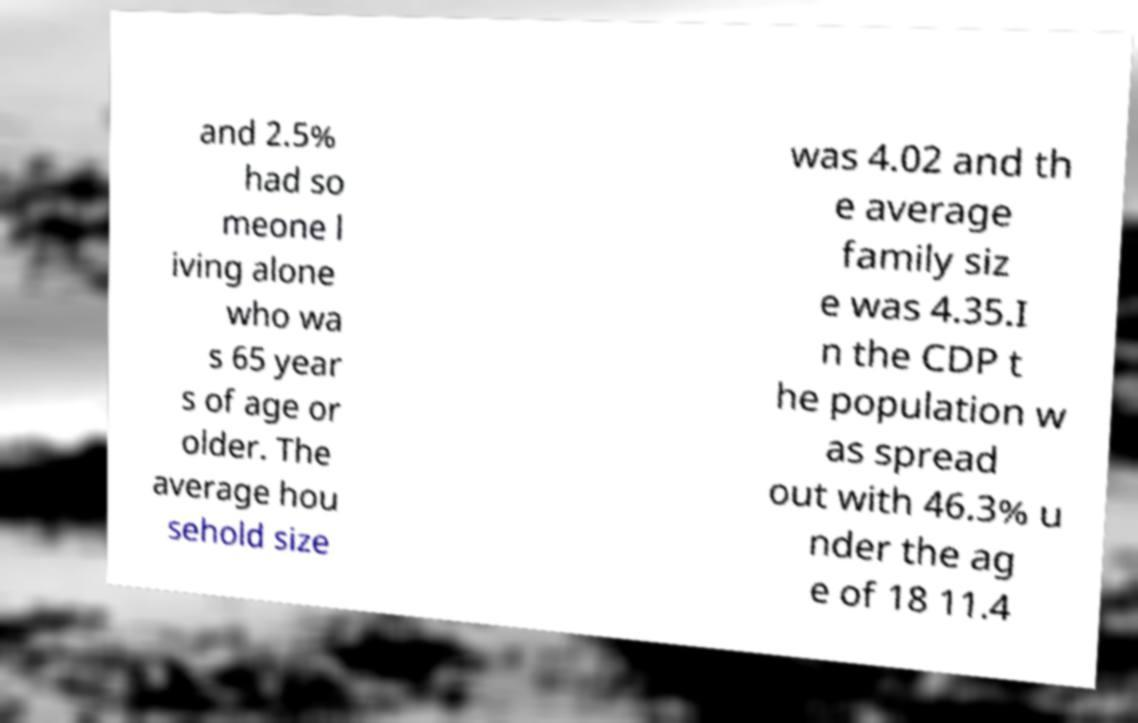Could you assist in decoding the text presented in this image and type it out clearly? and 2.5% had so meone l iving alone who wa s 65 year s of age or older. The average hou sehold size was 4.02 and th e average family siz e was 4.35.I n the CDP t he population w as spread out with 46.3% u nder the ag e of 18 11.4 